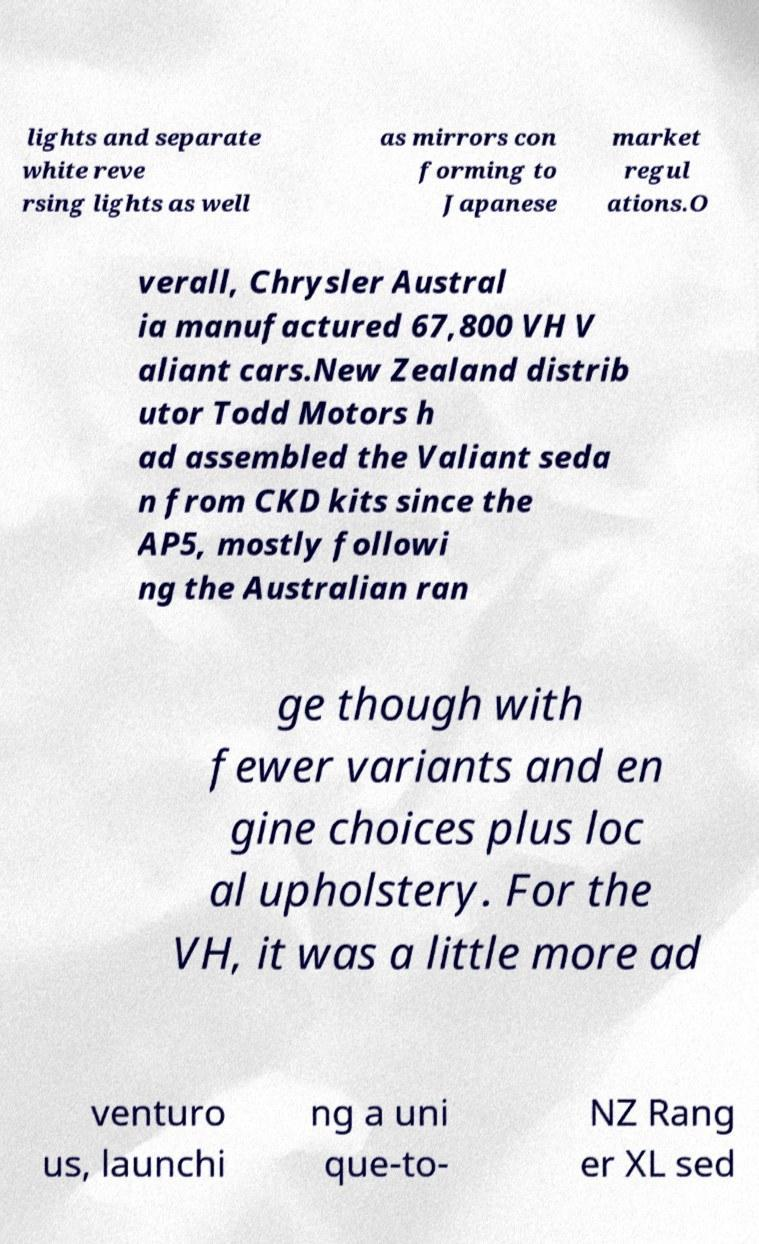For documentation purposes, I need the text within this image transcribed. Could you provide that? lights and separate white reve rsing lights as well as mirrors con forming to Japanese market regul ations.O verall, Chrysler Austral ia manufactured 67,800 VH V aliant cars.New Zealand distrib utor Todd Motors h ad assembled the Valiant seda n from CKD kits since the AP5, mostly followi ng the Australian ran ge though with fewer variants and en gine choices plus loc al upholstery. For the VH, it was a little more ad venturo us, launchi ng a uni que-to- NZ Rang er XL sed 